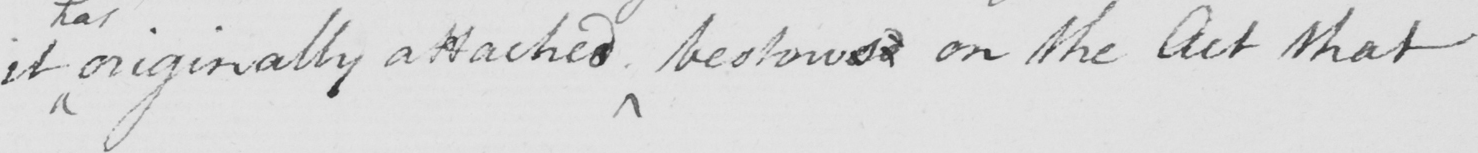Can you read and transcribe this handwriting? it originally attached bestowed on the Act that 